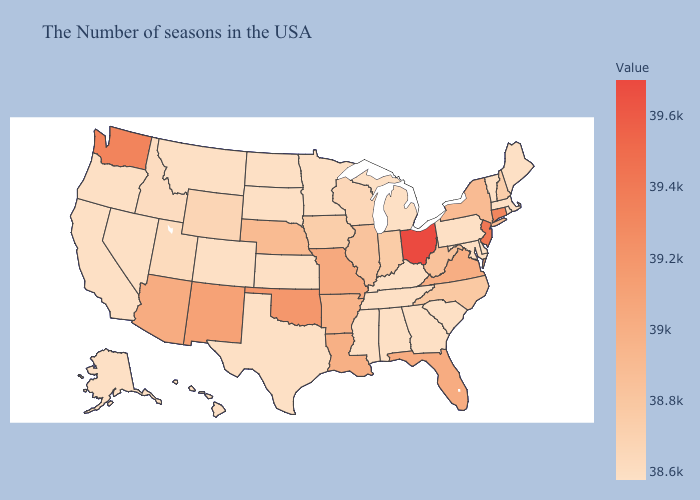Which states have the lowest value in the Northeast?
Give a very brief answer. Maine, Massachusetts, Rhode Island, Vermont, Pennsylvania. Among the states that border Alabama , which have the lowest value?
Short answer required. Georgia, Tennessee, Mississippi. Among the states that border Nebraska , which have the highest value?
Be succinct. Missouri. Does Wisconsin have the highest value in the MidWest?
Answer briefly. No. Which states have the lowest value in the West?
Keep it brief. Colorado, Montana, Nevada, California, Oregon, Alaska, Hawaii. Among the states that border New Jersey , which have the lowest value?
Quick response, please. Delaware, Pennsylvania. 